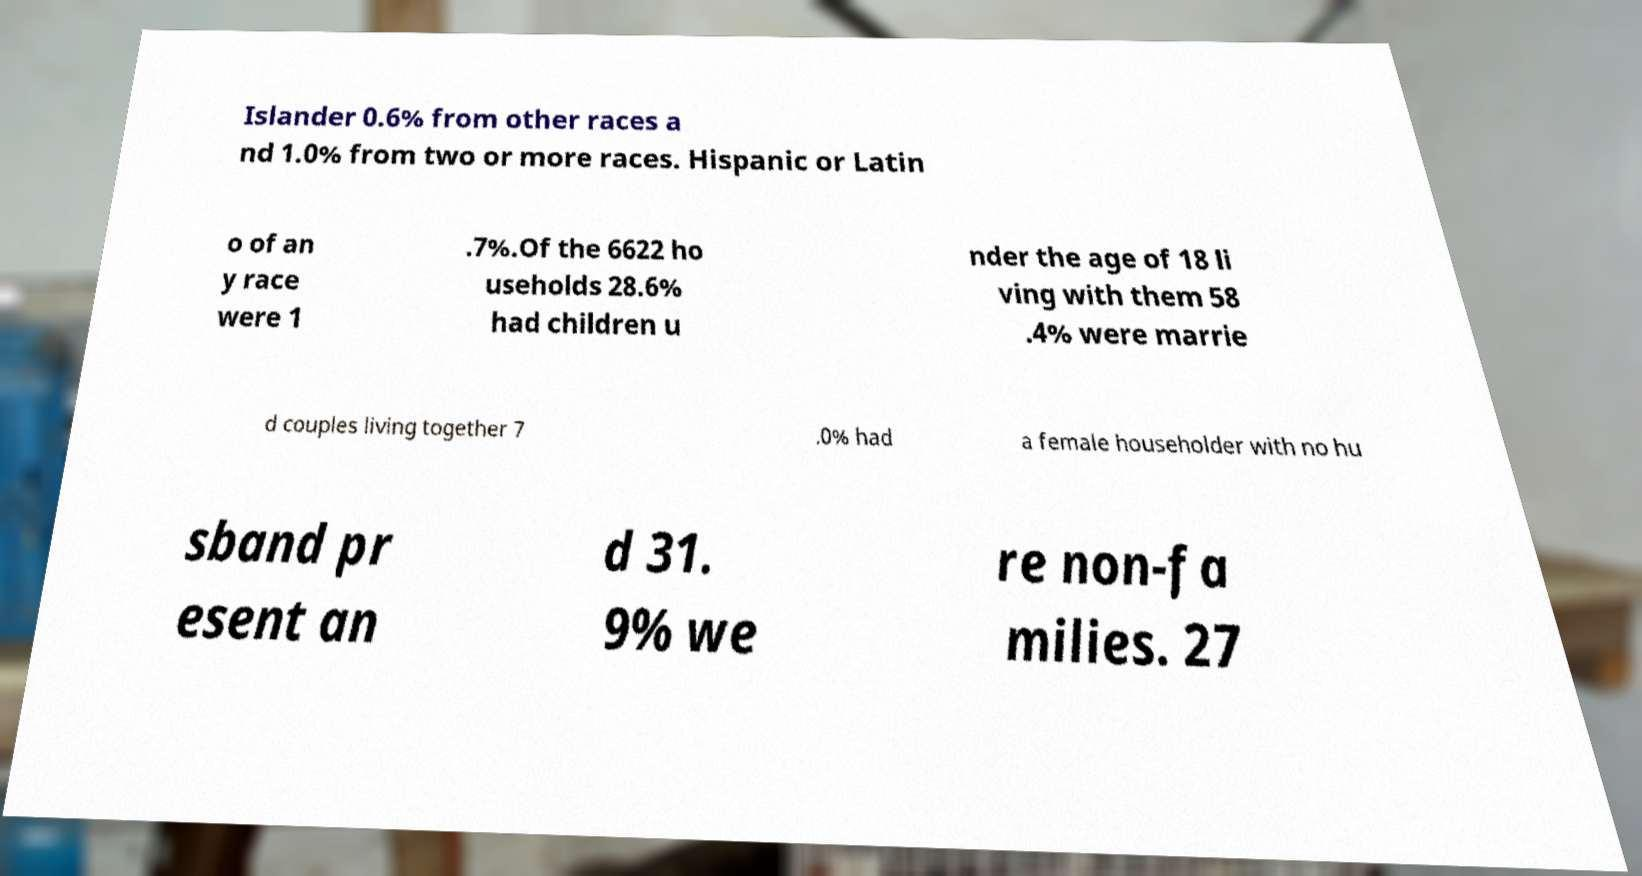Could you assist in decoding the text presented in this image and type it out clearly? Islander 0.6% from other races a nd 1.0% from two or more races. Hispanic or Latin o of an y race were 1 .7%.Of the 6622 ho useholds 28.6% had children u nder the age of 18 li ving with them 58 .4% were marrie d couples living together 7 .0% had a female householder with no hu sband pr esent an d 31. 9% we re non-fa milies. 27 